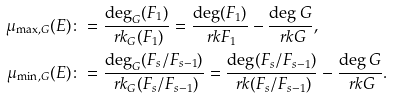<formula> <loc_0><loc_0><loc_500><loc_500>\mu _ { \max , G } ( E ) & \colon = \frac { \deg _ { G } ( F _ { 1 } ) } { \ r k _ { G } ( F _ { 1 } ) } = \frac { \deg ( F _ { 1 } ) } { \ r k F _ { 1 } } - \frac { \deg G } { \ r k G } , \\ \mu _ { \min , G } ( E ) & \colon = \frac { \deg _ { G } ( F _ { s } / F _ { s - 1 } ) } { \ r k _ { G } ( F _ { s } / F _ { s - 1 } ) } = \frac { \deg ( F _ { s } / F _ { s - 1 } ) } { \ r k ( F _ { s } / F _ { s - 1 } ) } - \frac { \deg G } { \ r k G } .</formula> 